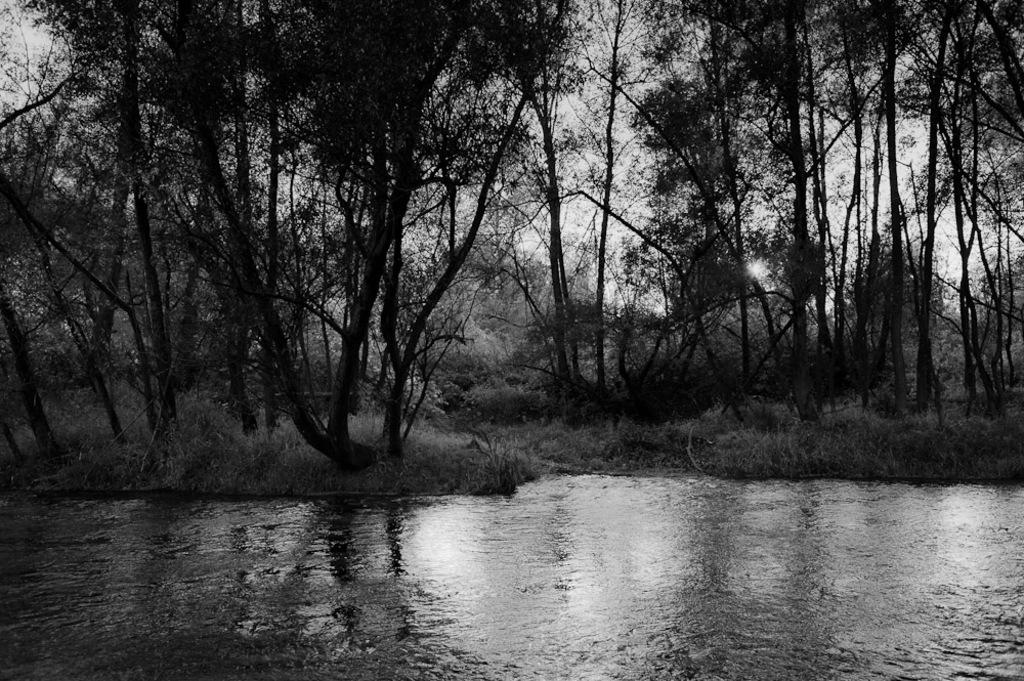What is the color scheme of the image? The image is black and white. What type of natural elements can be seen in the image? There are trees in the image. What is visible at the bottom of the image? There is water visible at the bottom of the image. How many apples are hanging from the trees in the image? There are no apples visible in the image; it only features trees and water. What type of brake is present in the image? There is no brake present in the image; it is a black and white image of trees and water. 